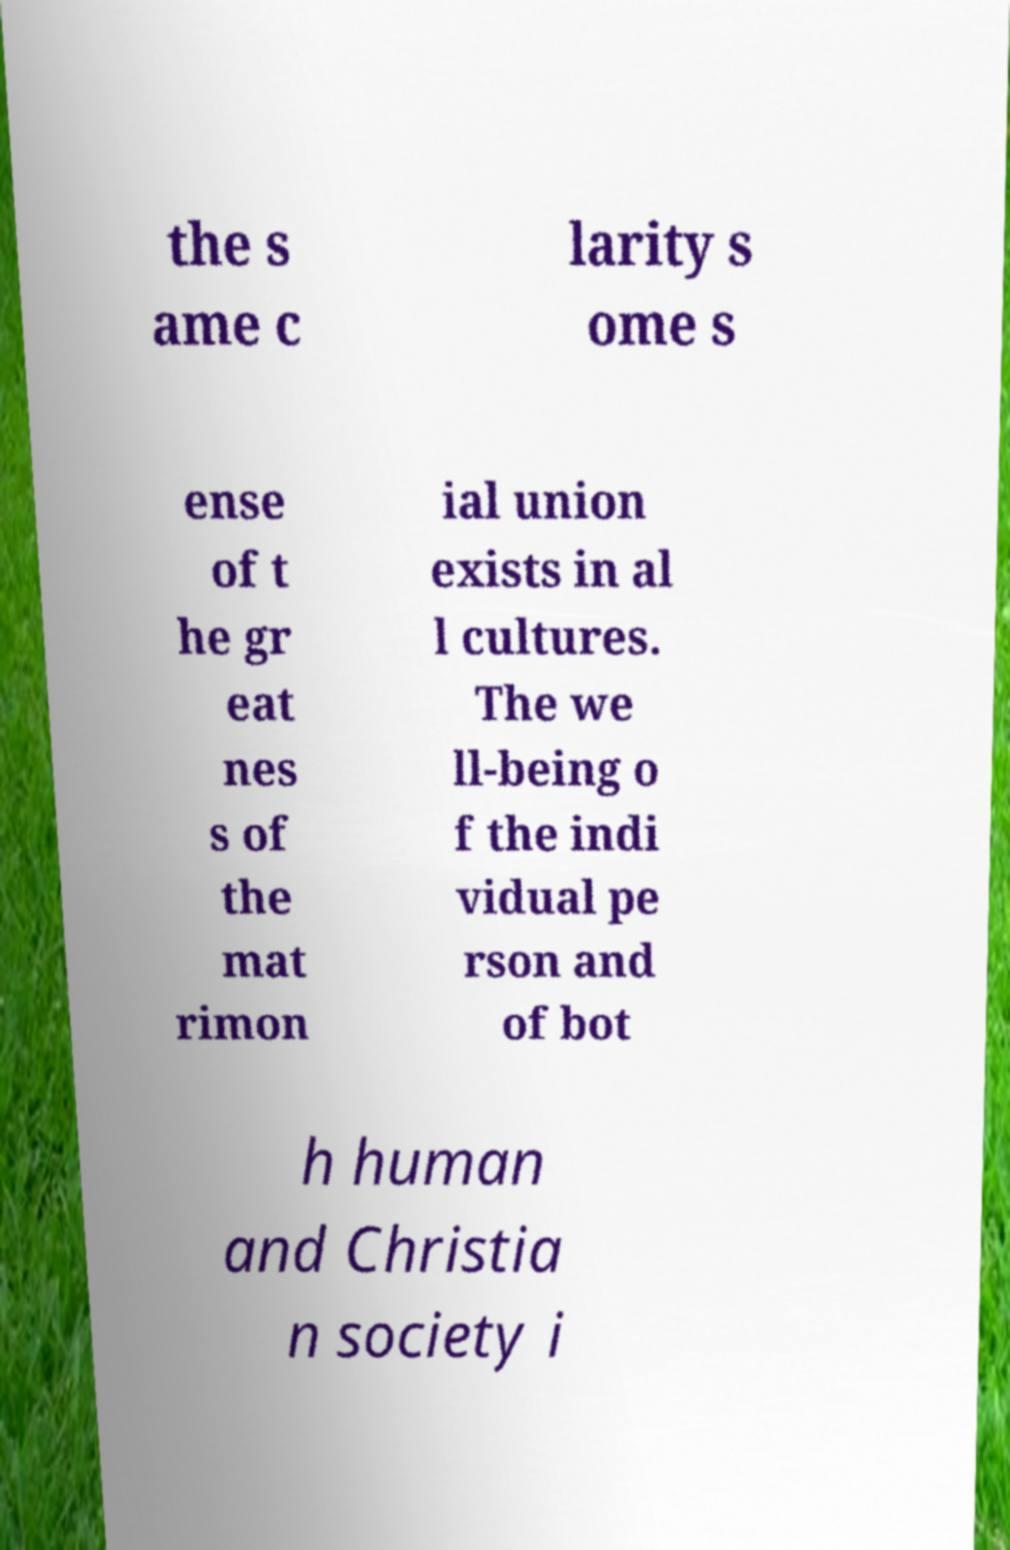There's text embedded in this image that I need extracted. Can you transcribe it verbatim? the s ame c larity s ome s ense of t he gr eat nes s of the mat rimon ial union exists in al l cultures. The we ll-being o f the indi vidual pe rson and of bot h human and Christia n society i 